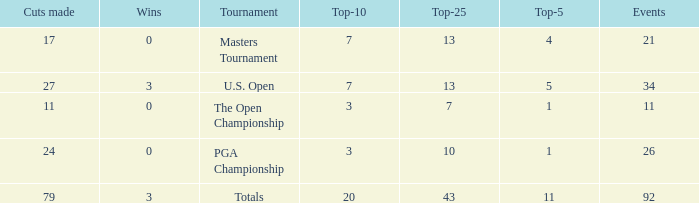Name the tournament for top-5 more thn 1 and top-25 of 13 with wins of 3 U.S. Open. Can you parse all the data within this table? {'header': ['Cuts made', 'Wins', 'Tournament', 'Top-10', 'Top-25', 'Top-5', 'Events'], 'rows': [['17', '0', 'Masters Tournament', '7', '13', '4', '21'], ['27', '3', 'U.S. Open', '7', '13', '5', '34'], ['11', '0', 'The Open Championship', '3', '7', '1', '11'], ['24', '0', 'PGA Championship', '3', '10', '1', '26'], ['79', '3', 'Totals', '20', '43', '11', '92']]} 